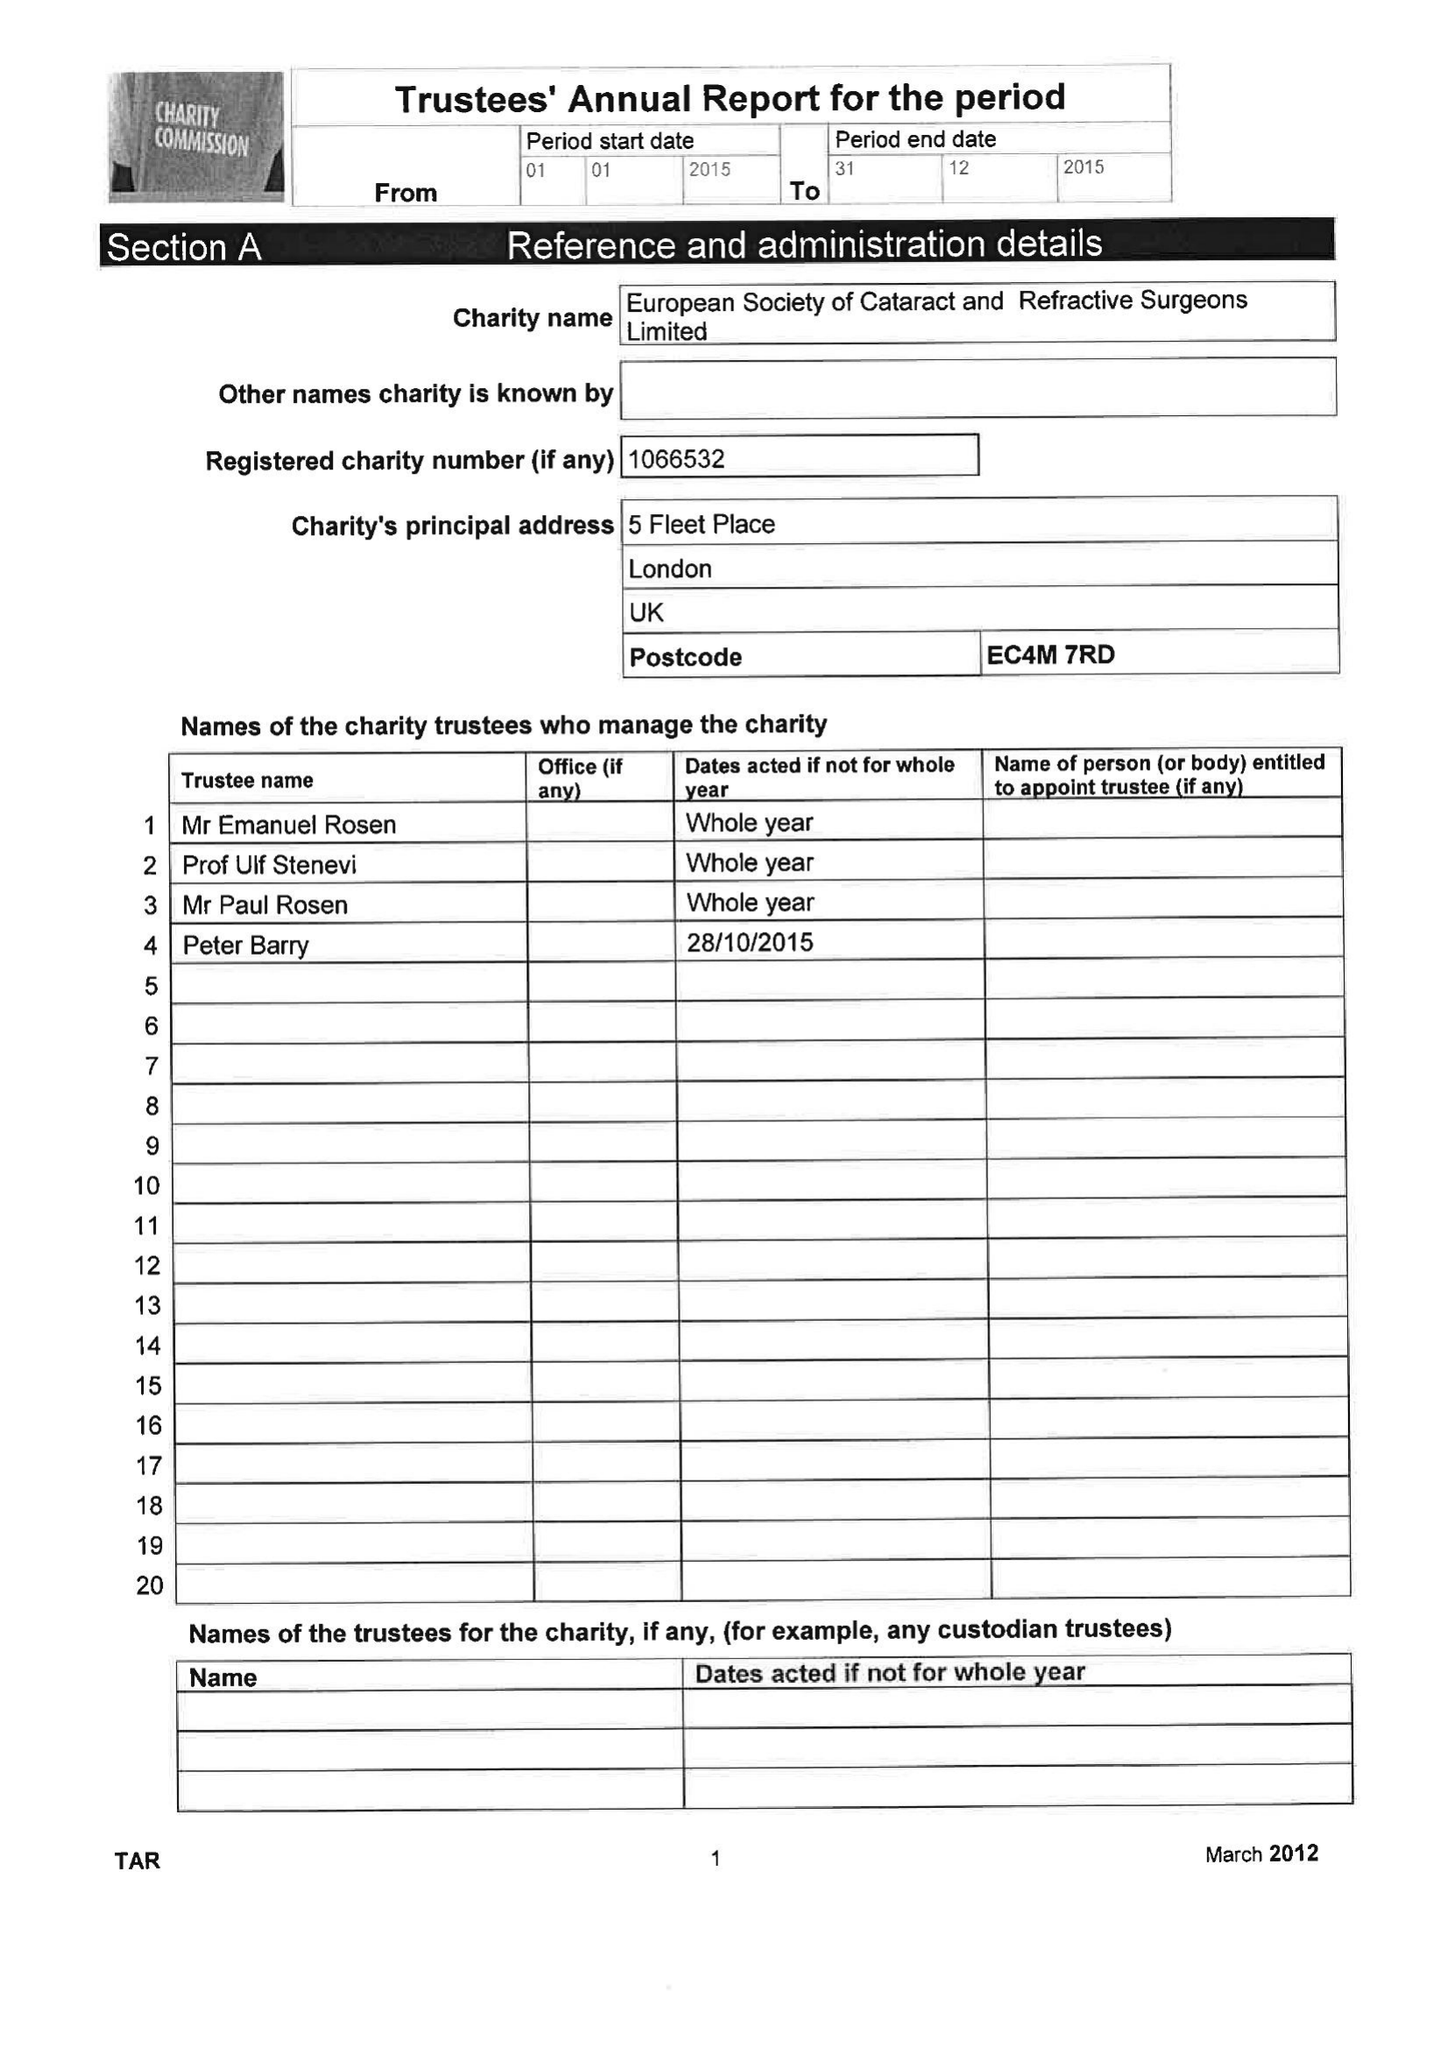What is the value for the report_date?
Answer the question using a single word or phrase. 2015-12-31 